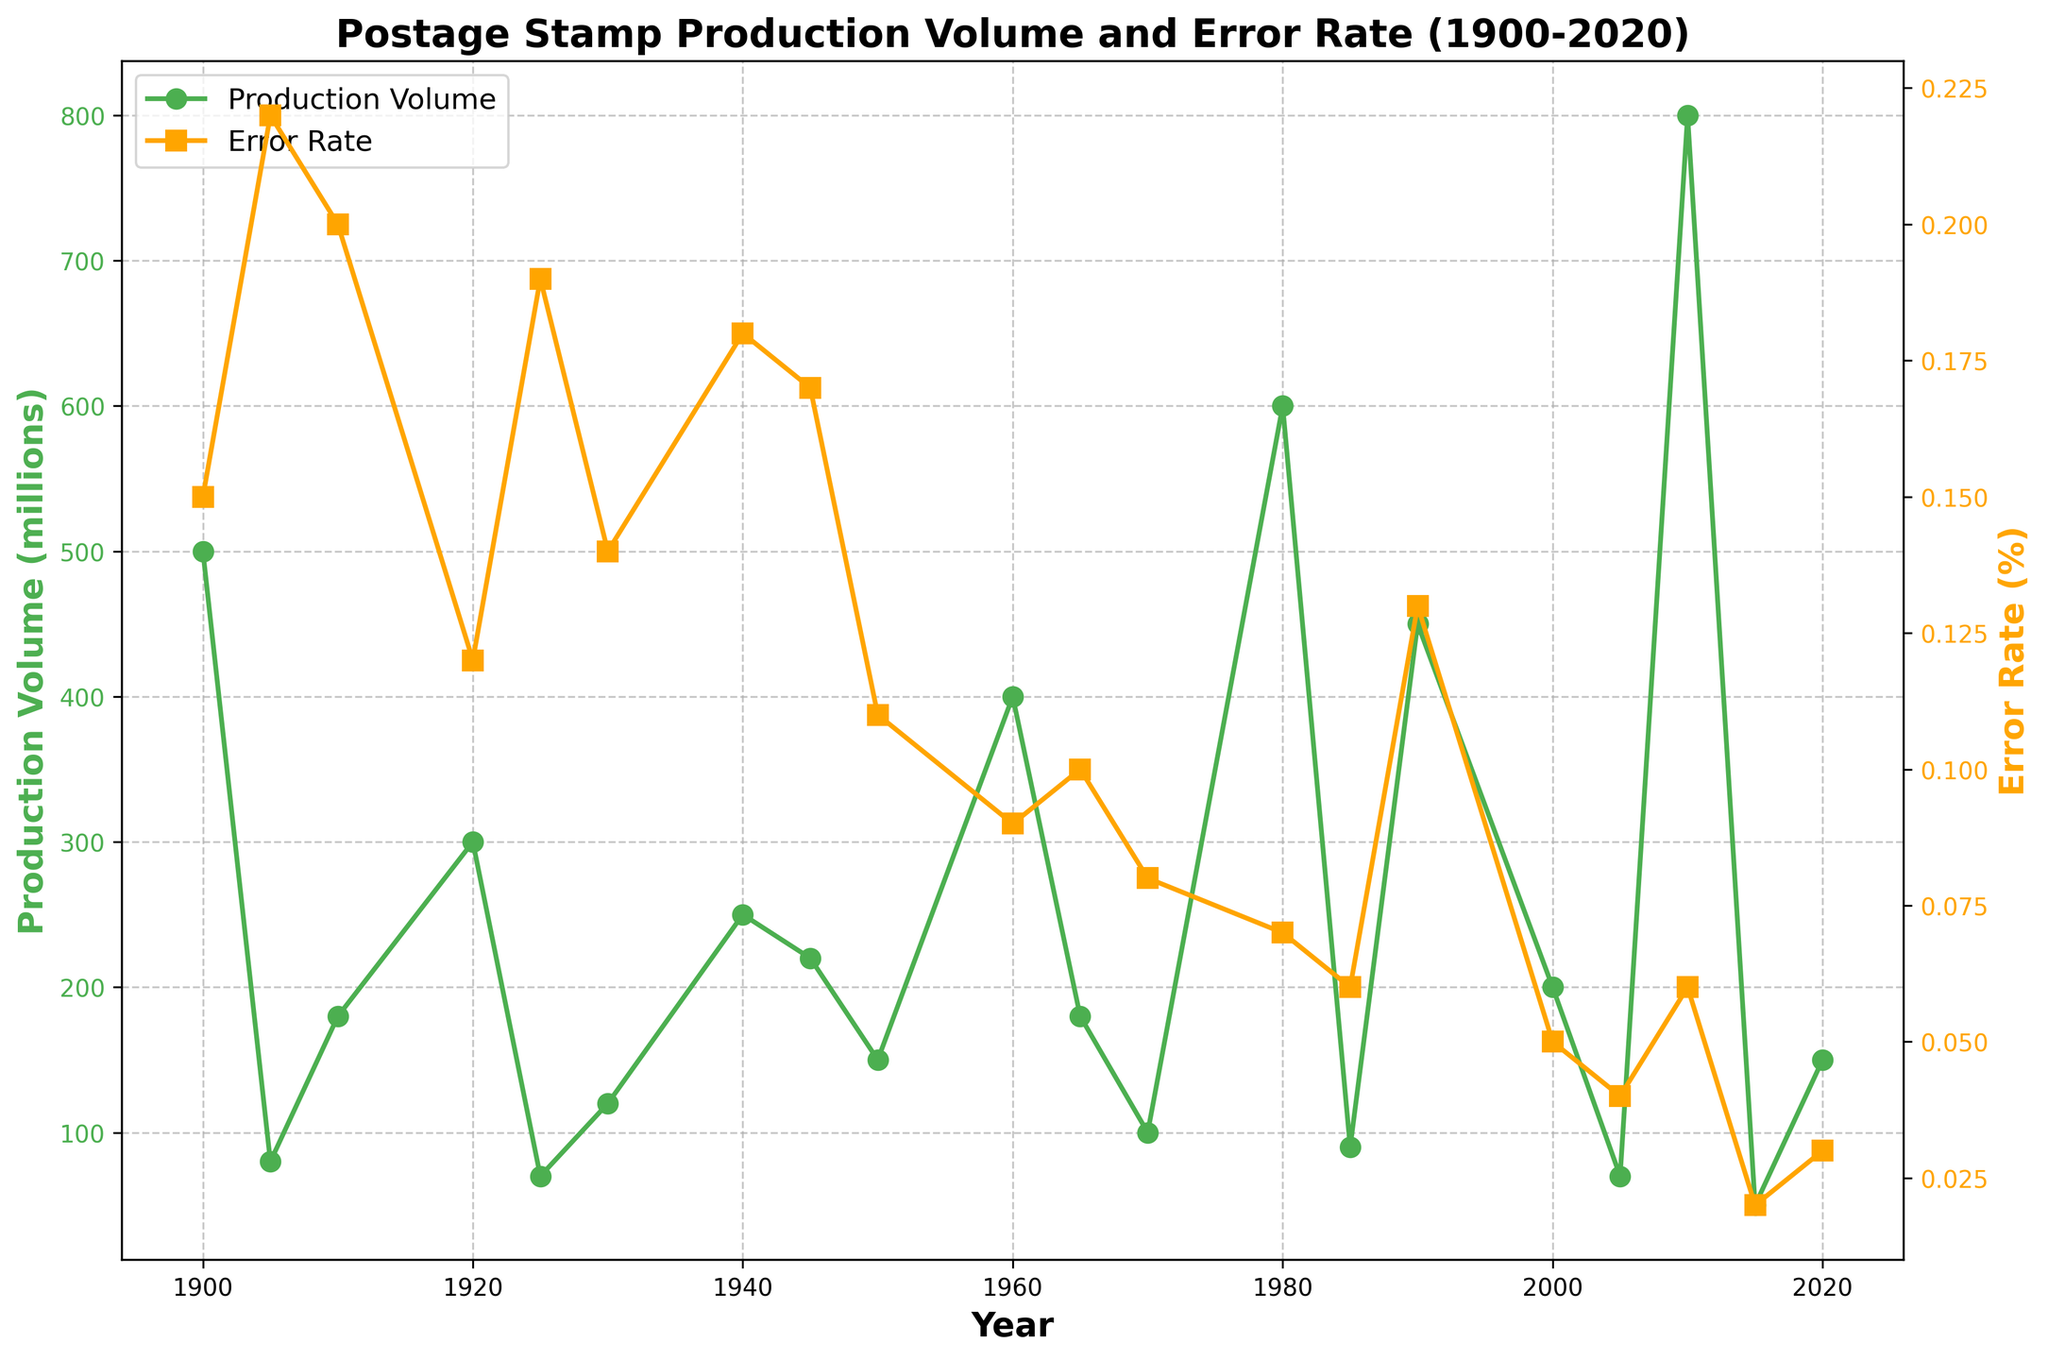Which country had the highest production volume of postage stamps in 2010? Look at the data points for the year 2010 and identify the country with the highest value on the production volume line. In this case, China had the highest production volume in 2010.
Answer: China What was the error rate (%) for stamps produced in Brazil in 1905? Locate the point that represents the error rate for Brazil in 1905 on the error rate line. The value is 0.22%.
Answer: 0.22% Compare the error rate of the United States in 1900 with that of Australia in 2020. Which country had a higher error rate? Identify the error rate for both countries and compare. The error rate for the United States in 1900 was 0.15%, while for Australia in 2020, it was 0.03%. The United States had a higher error rate.
Answer: United States What is the average production volume of postage stamps for the following years: 1900, 1920, 1940, 1960? Sum the production volumes for the years (500 + 300 + 250 + 400 = 1450) and divide by the number of years (1450 / 4 = 362.5).
Answer: 362.5 In which year did Japan have a significant decrease in error rate compared to the previous country’s data point, and what were the values? Compare Japan's error rate in 1980 (0.07%) to the previous data point, which is Switzerland in 1970 (0.08%). Calculate the decrease (0.08% - 0.07% = 0.01%).
Answer: 1980, 0.08%, 0.07% Is there a downward trend in the error rate over the years? Observe the overall slope of the error rate line from 1900 to 2020. The error rate generally decreases, indicating a downward trend.
Answer: Yes Which country shows both high production volume and low error rate in the same year? Identify the country that has both a high value on the production volume line and a low value on the error rate line. China in 2010 with a production volume of 800 million and an error rate of 0.06%.
Answer: China in 2010 What is the difference in production volume between India in 1945 and Sweden in 1930? Find the production volumes for India in 1945 (220 million) and Sweden in 1930 (120 million), then calculate the difference (220 - 120 = 100).
Answer: 100 Compare the error rates between Italy in 1910 and Spain in 1965. What is the difference in percentage points? Locate the error rates for Italy in 1910 (0.20%) and Spain in 1965 (0.10%). Subtract the values (0.20% - 0.10% = 0.10%).
Answer: 0.10% Which country in the 1980s had the lowest error rate and what was the rate? Examine the data points in the 1980s and identify the country with the lowest value on the error rate line. Belgium in 1985 with an error rate of 0.06%.
Answer: Belgium, 0.06% 